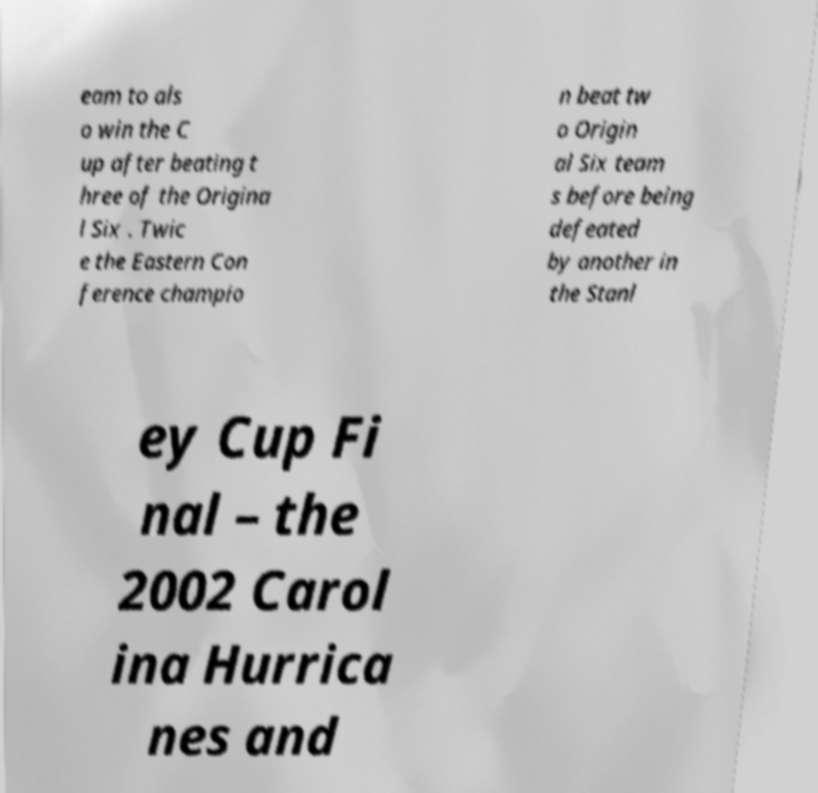There's text embedded in this image that I need extracted. Can you transcribe it verbatim? eam to als o win the C up after beating t hree of the Origina l Six . Twic e the Eastern Con ference champio n beat tw o Origin al Six team s before being defeated by another in the Stanl ey Cup Fi nal – the 2002 Carol ina Hurrica nes and 